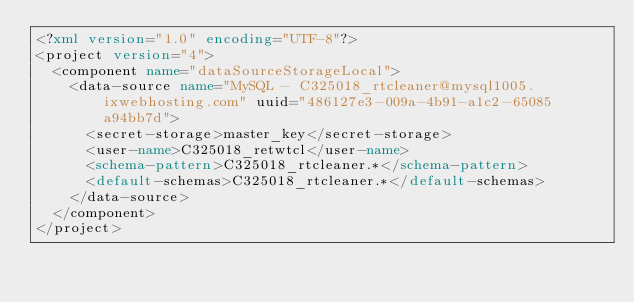<code> <loc_0><loc_0><loc_500><loc_500><_XML_><?xml version="1.0" encoding="UTF-8"?>
<project version="4">
  <component name="dataSourceStorageLocal">
    <data-source name="MySQL - C325018_rtcleaner@mysql1005.ixwebhosting.com" uuid="486127e3-009a-4b91-a1c2-65085a94bb7d">
      <secret-storage>master_key</secret-storage>
      <user-name>C325018_retwtcl</user-name>
      <schema-pattern>C325018_rtcleaner.*</schema-pattern>
      <default-schemas>C325018_rtcleaner.*</default-schemas>
    </data-source>
  </component>
</project></code> 